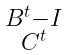Convert formula to latex. <formula><loc_0><loc_0><loc_500><loc_500>\begin{smallmatrix} B ^ { t } - I \\ C ^ { t } \\ \end{smallmatrix}</formula> 